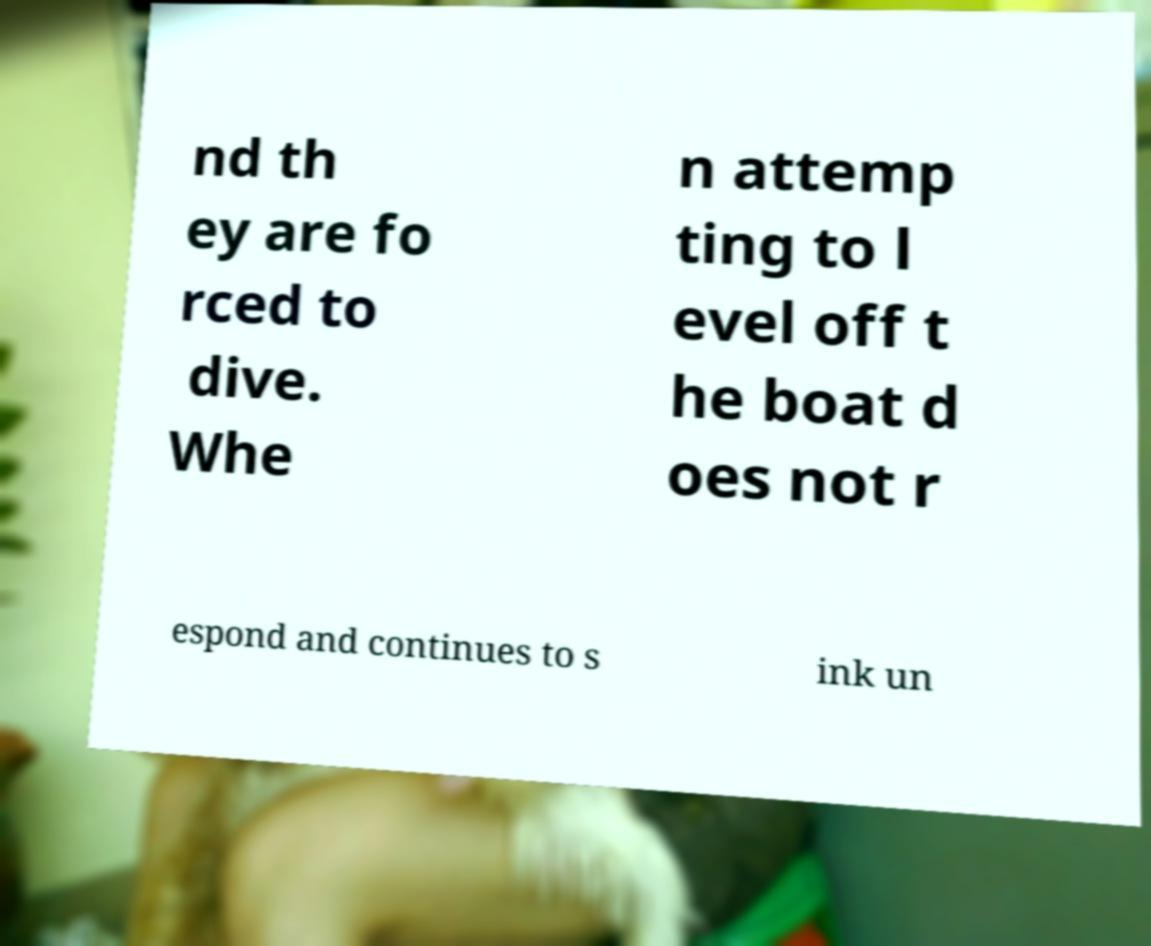Can you accurately transcribe the text from the provided image for me? nd th ey are fo rced to dive. Whe n attemp ting to l evel off t he boat d oes not r espond and continues to s ink un 